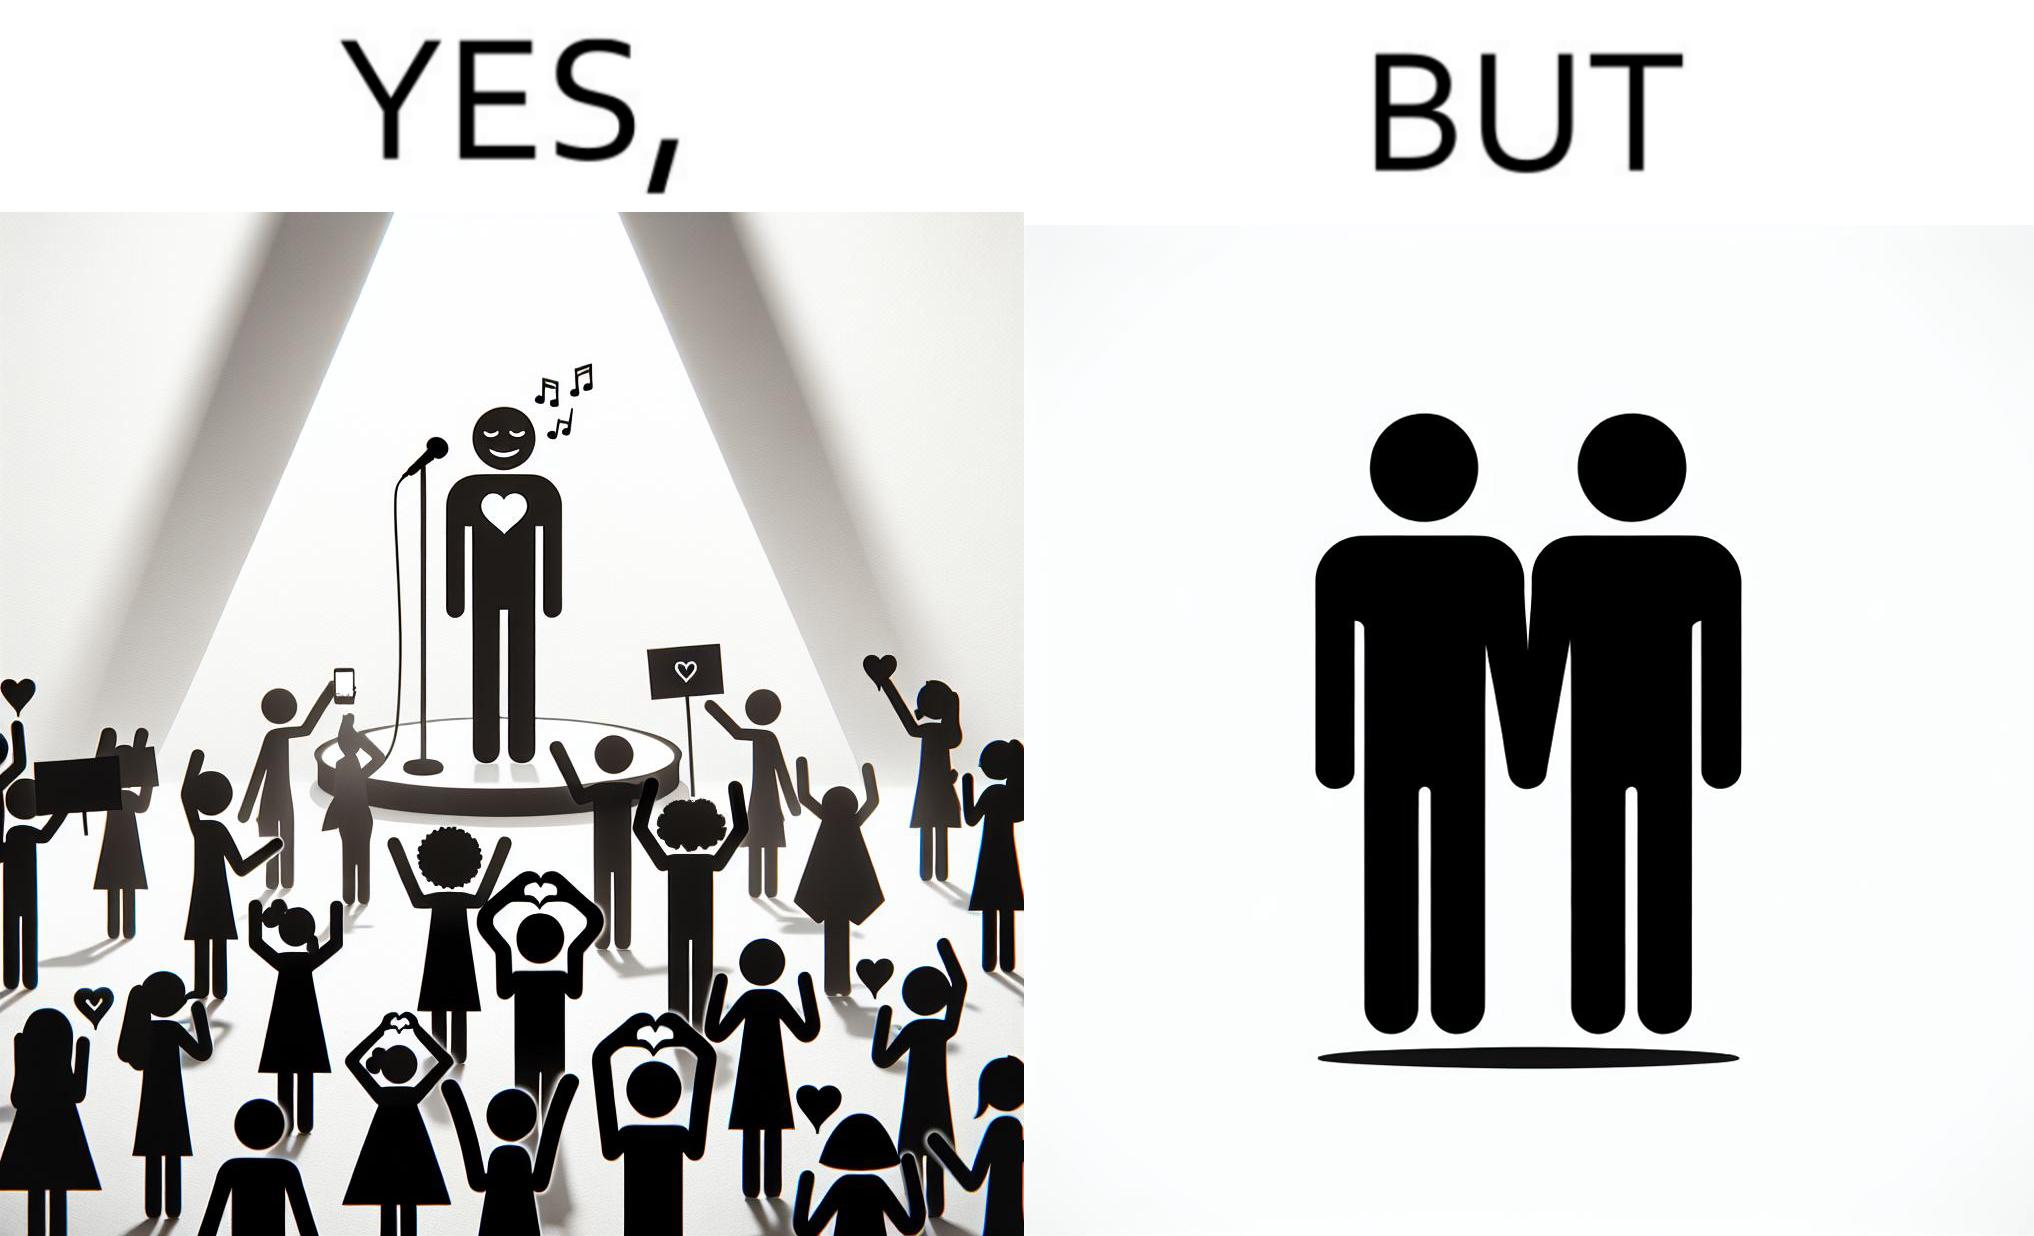What is shown in this image? The image is funny because while the girls loves the man, he likes other men instead of women. 